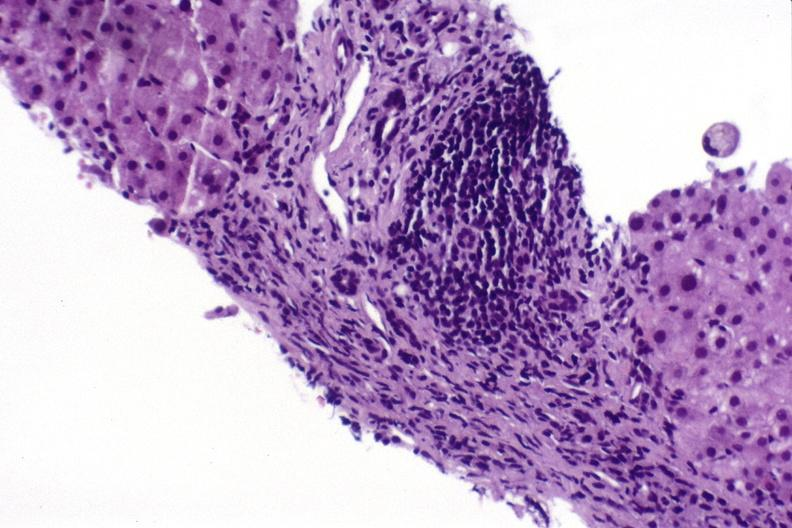s intrauterine contraceptive device present?
Answer the question using a single word or phrase. No 